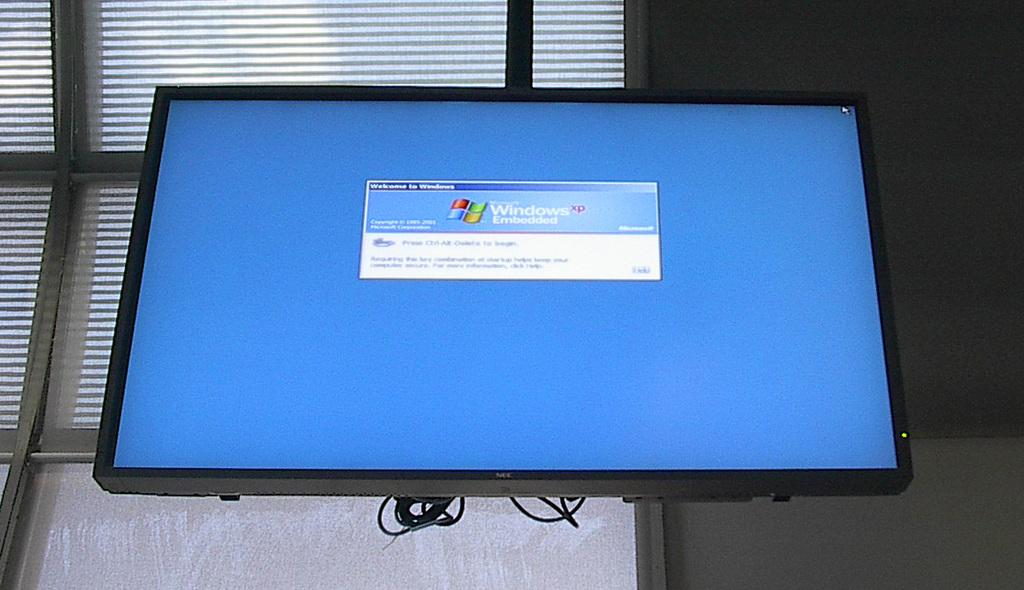<image>
Summarize the visual content of the image. A blue computer screen has a small window that says Windows XP Embedded. 